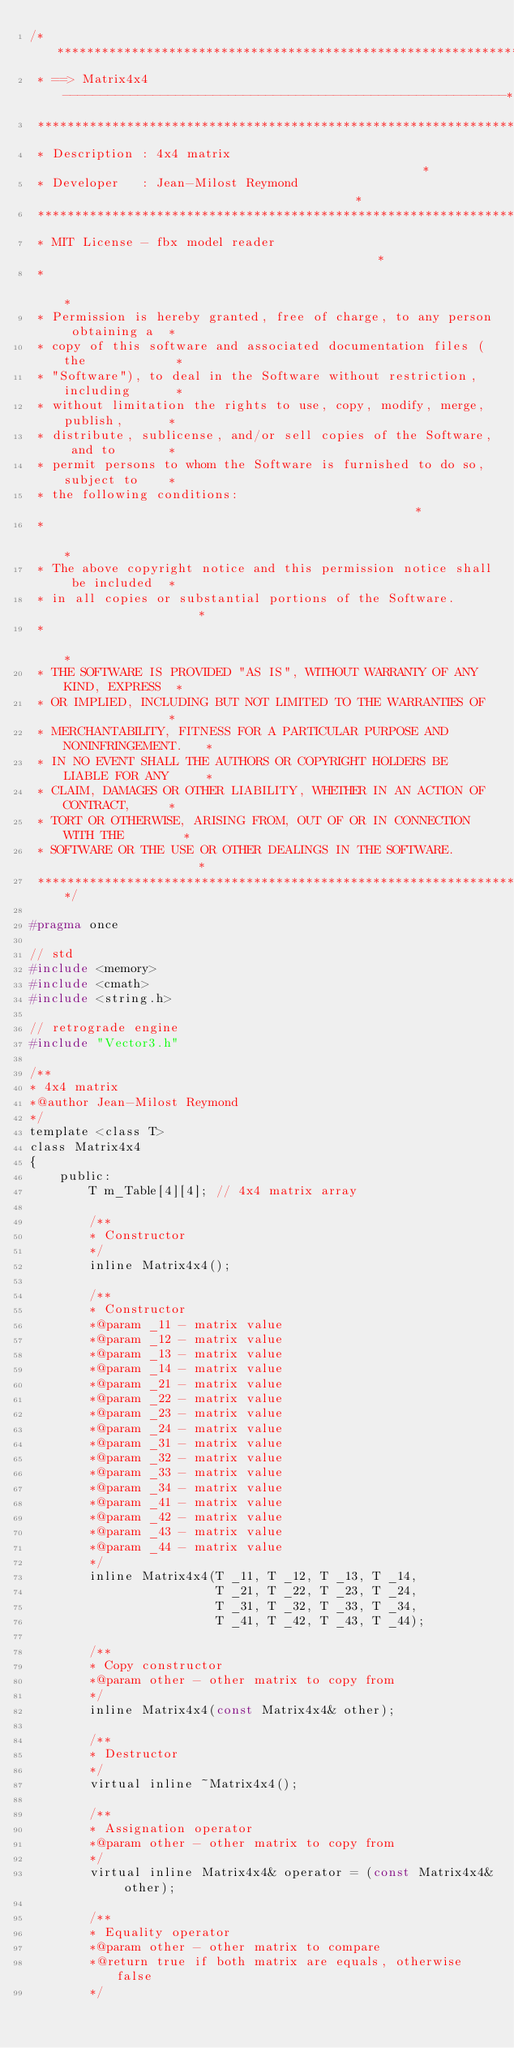Convert code to text. <code><loc_0><loc_0><loc_500><loc_500><_C_>/****************************************************************************
 * ==> Matrix4x4 -----------------------------------------------------------*
 ****************************************************************************
 * Description : 4x4 matrix                                                 *
 * Developer   : Jean-Milost Reymond                                        *
 ****************************************************************************
 * MIT License - fbx model reader                                           *
 *                                                                          *
 * Permission is hereby granted, free of charge, to any person obtaining a  *
 * copy of this software and associated documentation files (the            *
 * "Software"), to deal in the Software without restriction, including      *
 * without limitation the rights to use, copy, modify, merge, publish,      *
 * distribute, sublicense, and/or sell copies of the Software, and to       *
 * permit persons to whom the Software is furnished to do so, subject to    *
 * the following conditions:                                                *
 *                                                                          *
 * The above copyright notice and this permission notice shall be included  *
 * in all copies or substantial portions of the Software.                   *
 *                                                                          *
 * THE SOFTWARE IS PROVIDED "AS IS", WITHOUT WARRANTY OF ANY KIND, EXPRESS  *
 * OR IMPLIED, INCLUDING BUT NOT LIMITED TO THE WARRANTIES OF               *
 * MERCHANTABILITY, FITNESS FOR A PARTICULAR PURPOSE AND NONINFRINGEMENT.   *
 * IN NO EVENT SHALL THE AUTHORS OR COPYRIGHT HOLDERS BE LIABLE FOR ANY     *
 * CLAIM, DAMAGES OR OTHER LIABILITY, WHETHER IN AN ACTION OF CONTRACT,     *
 * TORT OR OTHERWISE, ARISING FROM, OUT OF OR IN CONNECTION WITH THE        *
 * SOFTWARE OR THE USE OR OTHER DEALINGS IN THE SOFTWARE.                   *
 ****************************************************************************/

#pragma once

// std
#include <memory>
#include <cmath>
#include <string.h>

// retrograde engine
#include "Vector3.h"

/**
* 4x4 matrix
*@author Jean-Milost Reymond
*/
template <class T>
class Matrix4x4
{
    public:
        T m_Table[4][4]; // 4x4 matrix array

        /**
        * Constructor
        */
        inline Matrix4x4();

        /**
        * Constructor
        *@param _11 - matrix value
        *@param _12 - matrix value
        *@param _13 - matrix value
        *@param _14 - matrix value
        *@param _21 - matrix value
        *@param _22 - matrix value
        *@param _23 - matrix value
        *@param _24 - matrix value
        *@param _31 - matrix value
        *@param _32 - matrix value
        *@param _33 - matrix value
        *@param _34 - matrix value
        *@param _41 - matrix value
        *@param _42 - matrix value
        *@param _43 - matrix value
        *@param _44 - matrix value
        */
        inline Matrix4x4(T _11, T _12, T _13, T _14,
                         T _21, T _22, T _23, T _24,
                         T _31, T _32, T _33, T _34,
                         T _41, T _42, T _43, T _44);

        /**
        * Copy constructor
        *@param other - other matrix to copy from
        */
        inline Matrix4x4(const Matrix4x4& other);

        /**
        * Destructor
        */
        virtual inline ~Matrix4x4();

        /**
        * Assignation operator
        *@param other - other matrix to copy from
        */
        virtual inline Matrix4x4& operator = (const Matrix4x4& other);

        /**
        * Equality operator
        *@param other - other matrix to compare
        *@return true if both matrix are equals, otherwise false
        */</code> 